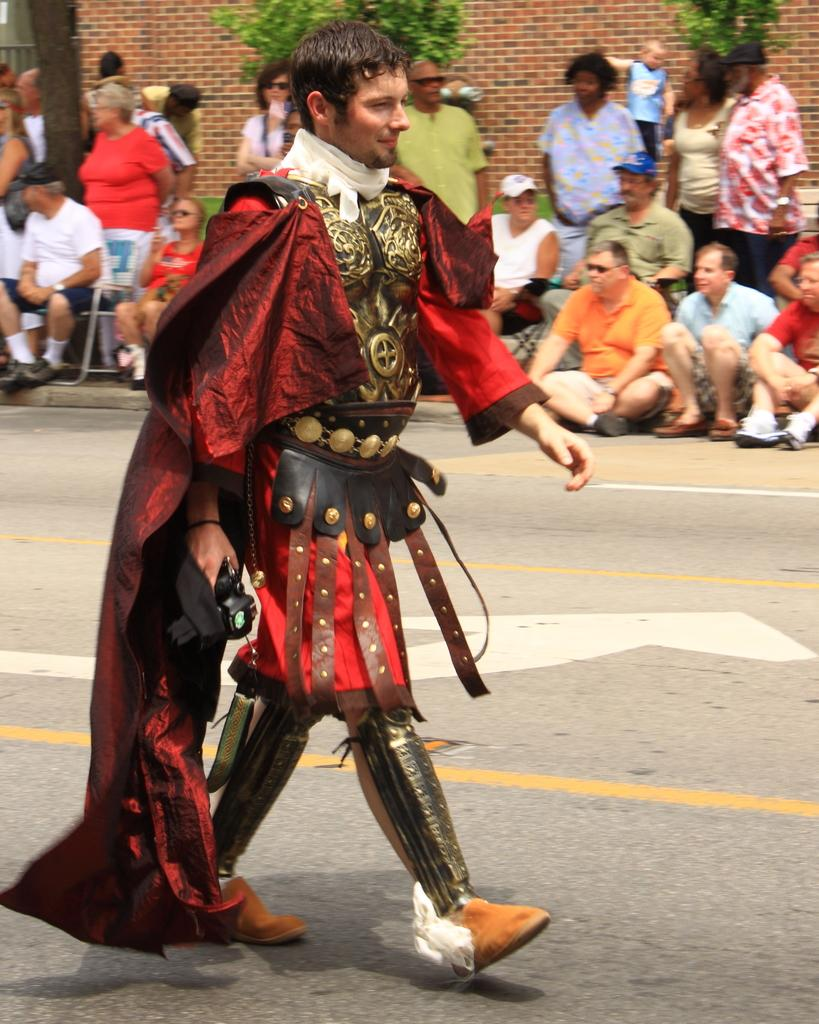What is the main subject of the image? There is a man in the image. What is the man doing in the image? The man is walking on the road. Can you describe the man's appearance? The man is wearing a costume. What can be seen in the background of the image? There is a group of people, a wall, plants, and some objects in the background of the image. What type of popcorn is being served to the manager in the image? There is no manager or popcorn present in the image. What is the base of the costume the man is wearing in the image? The provided facts do not mention the base of the costume the man is wearing. 